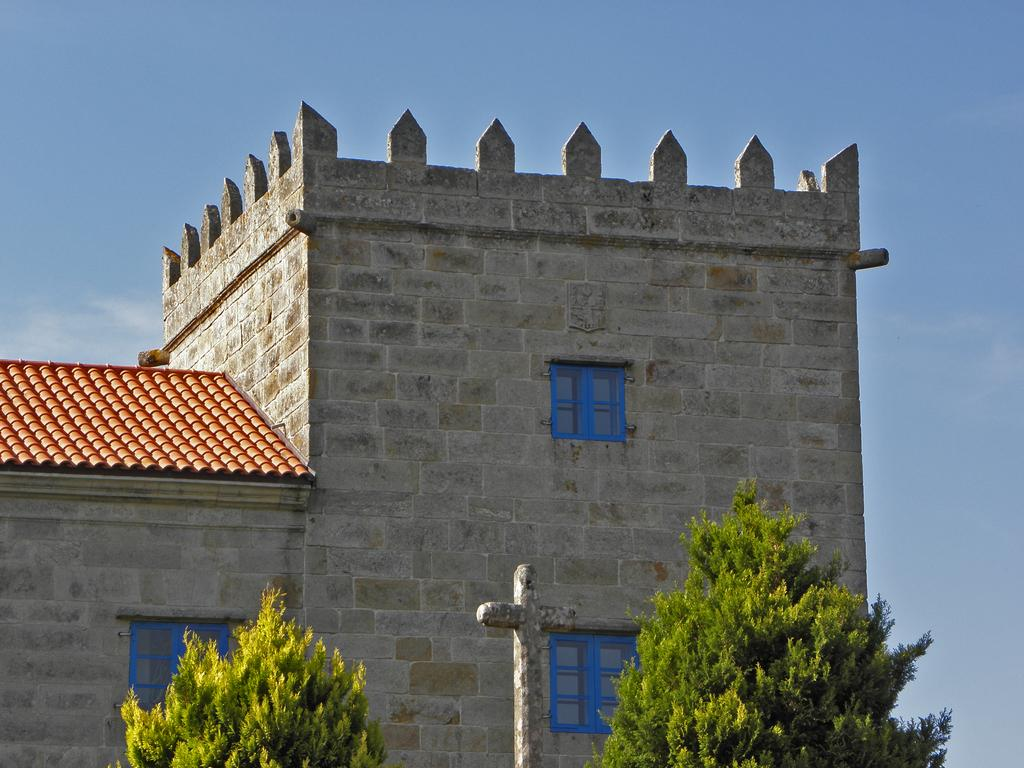What type of structure is visible in the image? There is a building with three windows in the image. What can be seen in the foreground of the image? There are two trees and a statue in the foreground of the image. What is visible in the background of the image? The sky is visible in the background of the image. How many lawyers are walking with balls in the image? There are no lawyers or balls present in the image. 